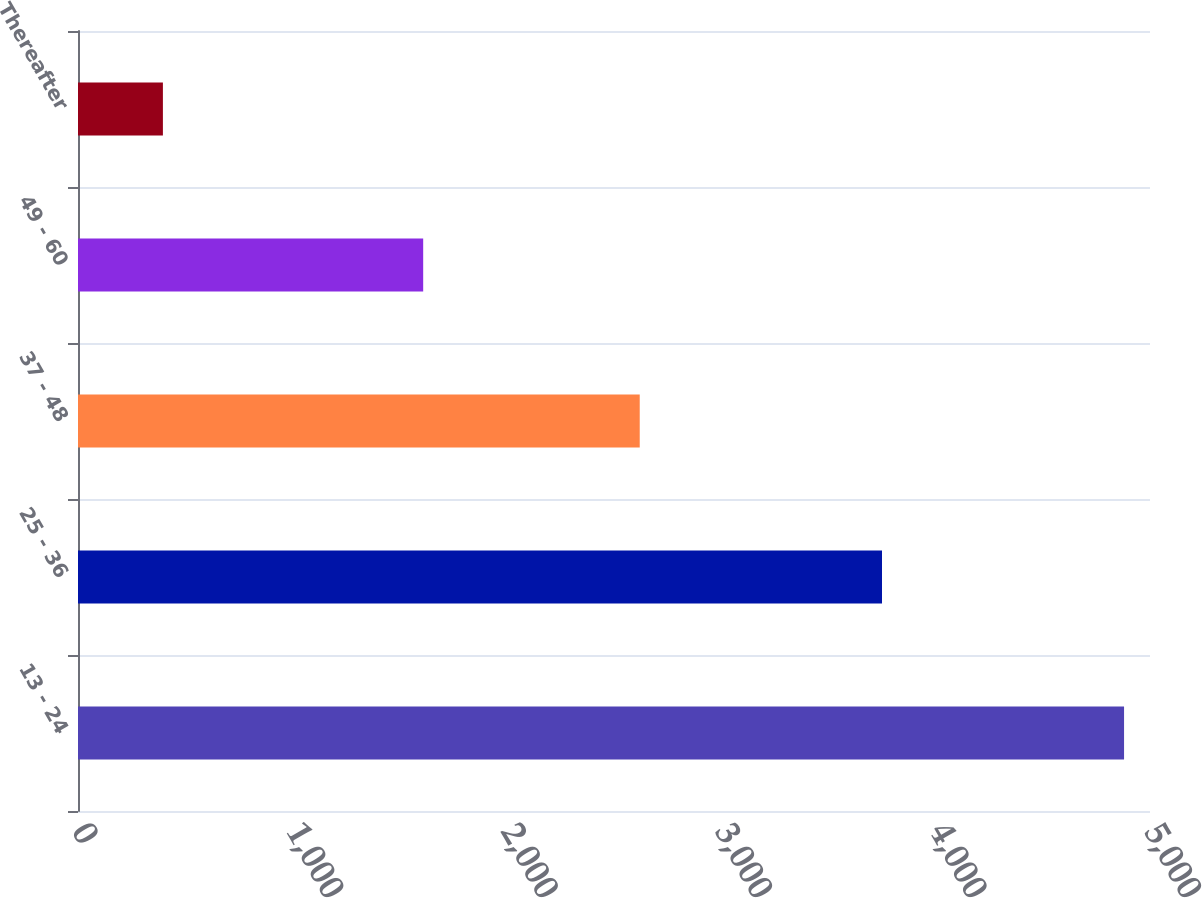Convert chart to OTSL. <chart><loc_0><loc_0><loc_500><loc_500><bar_chart><fcel>13 - 24<fcel>25 - 36<fcel>37 - 48<fcel>49 - 60<fcel>Thereafter<nl><fcel>4879<fcel>3750<fcel>2620<fcel>1610<fcel>396<nl></chart> 